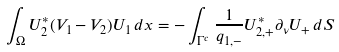Convert formula to latex. <formula><loc_0><loc_0><loc_500><loc_500>\int _ { \Omega } U _ { 2 } ^ { * } ( V _ { 1 } - V _ { 2 } ) U _ { 1 } \, d x = - \int _ { \Gamma ^ { c } } \frac { 1 } { q _ { 1 , - } } U _ { 2 , + } ^ { * } \partial _ { \nu } U _ { + } \, d S</formula> 